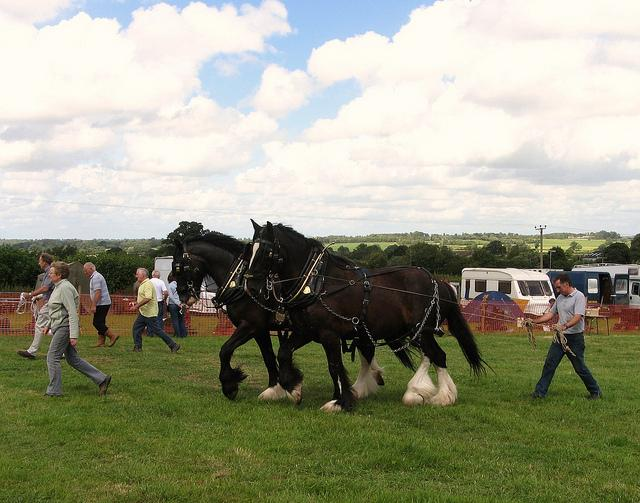Where can the people potentially sleep? Please explain your reasoning. trailer. You can't sleep on a horse. you need some sort of shelter and a trailer is the appropriate size, a car is too small. sleeping in the field offers no shelter. 